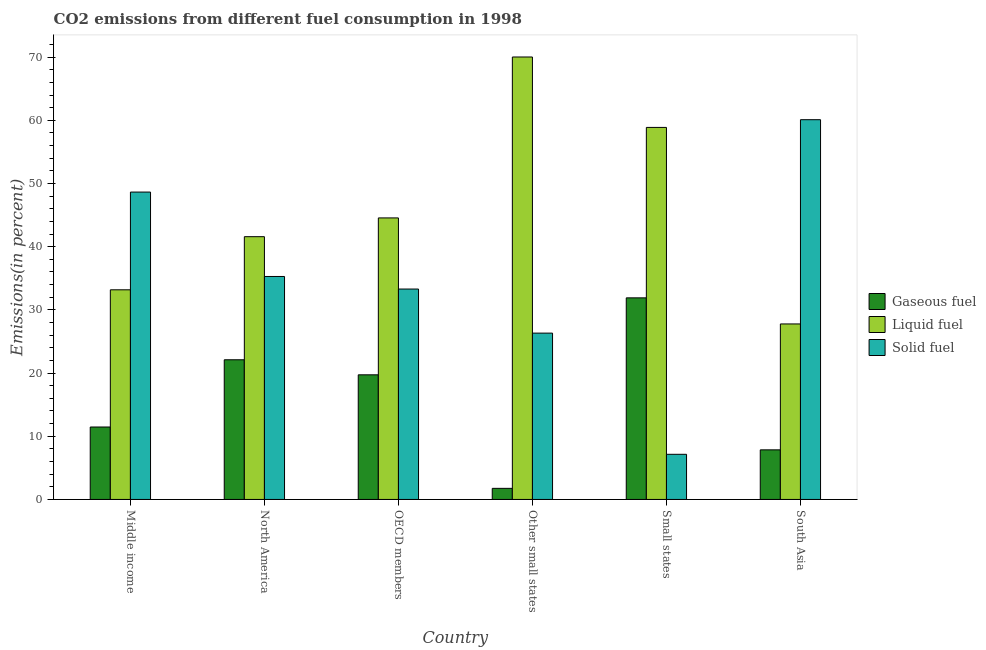How many groups of bars are there?
Give a very brief answer. 6. Are the number of bars per tick equal to the number of legend labels?
Provide a succinct answer. Yes. How many bars are there on the 1st tick from the right?
Keep it short and to the point. 3. What is the label of the 3rd group of bars from the left?
Make the answer very short. OECD members. In how many cases, is the number of bars for a given country not equal to the number of legend labels?
Keep it short and to the point. 0. What is the percentage of gaseous fuel emission in South Asia?
Your response must be concise. 7.85. Across all countries, what is the maximum percentage of gaseous fuel emission?
Your answer should be compact. 31.9. Across all countries, what is the minimum percentage of solid fuel emission?
Provide a succinct answer. 7.14. In which country was the percentage of liquid fuel emission maximum?
Give a very brief answer. Other small states. What is the total percentage of gaseous fuel emission in the graph?
Offer a terse response. 94.81. What is the difference between the percentage of liquid fuel emission in Other small states and that in Small states?
Provide a short and direct response. 11.14. What is the difference between the percentage of solid fuel emission in OECD members and the percentage of gaseous fuel emission in North America?
Keep it short and to the point. 11.19. What is the average percentage of gaseous fuel emission per country?
Your response must be concise. 15.8. What is the difference between the percentage of solid fuel emission and percentage of gaseous fuel emission in Middle income?
Give a very brief answer. 37.18. In how many countries, is the percentage of liquid fuel emission greater than 58 %?
Your response must be concise. 2. What is the ratio of the percentage of solid fuel emission in Middle income to that in Other small states?
Provide a succinct answer. 1.85. Is the percentage of gaseous fuel emission in Middle income less than that in Other small states?
Provide a succinct answer. No. Is the difference between the percentage of liquid fuel emission in Middle income and OECD members greater than the difference between the percentage of gaseous fuel emission in Middle income and OECD members?
Keep it short and to the point. No. What is the difference between the highest and the second highest percentage of liquid fuel emission?
Ensure brevity in your answer.  11.14. What is the difference between the highest and the lowest percentage of gaseous fuel emission?
Your answer should be very brief. 30.15. In how many countries, is the percentage of solid fuel emission greater than the average percentage of solid fuel emission taken over all countries?
Your response must be concise. 3. Is the sum of the percentage of gaseous fuel emission in Middle income and Small states greater than the maximum percentage of liquid fuel emission across all countries?
Your response must be concise. No. What does the 2nd bar from the left in North America represents?
Keep it short and to the point. Liquid fuel. What does the 1st bar from the right in South Asia represents?
Ensure brevity in your answer.  Solid fuel. Is it the case that in every country, the sum of the percentage of gaseous fuel emission and percentage of liquid fuel emission is greater than the percentage of solid fuel emission?
Offer a very short reply. No. How many bars are there?
Your answer should be compact. 18. Are all the bars in the graph horizontal?
Your answer should be very brief. No. How many countries are there in the graph?
Make the answer very short. 6. Does the graph contain any zero values?
Your response must be concise. No. Where does the legend appear in the graph?
Your answer should be very brief. Center right. How many legend labels are there?
Provide a short and direct response. 3. What is the title of the graph?
Ensure brevity in your answer.  CO2 emissions from different fuel consumption in 1998. Does "Natural gas sources" appear as one of the legend labels in the graph?
Keep it short and to the point. No. What is the label or title of the X-axis?
Your answer should be compact. Country. What is the label or title of the Y-axis?
Your answer should be compact. Emissions(in percent). What is the Emissions(in percent) in Gaseous fuel in Middle income?
Provide a short and direct response. 11.47. What is the Emissions(in percent) of Liquid fuel in Middle income?
Your answer should be very brief. 33.18. What is the Emissions(in percent) of Solid fuel in Middle income?
Provide a succinct answer. 48.64. What is the Emissions(in percent) in Gaseous fuel in North America?
Your answer should be compact. 22.11. What is the Emissions(in percent) in Liquid fuel in North America?
Your answer should be very brief. 41.59. What is the Emissions(in percent) of Solid fuel in North America?
Keep it short and to the point. 35.29. What is the Emissions(in percent) in Gaseous fuel in OECD members?
Provide a short and direct response. 19.73. What is the Emissions(in percent) of Liquid fuel in OECD members?
Keep it short and to the point. 44.55. What is the Emissions(in percent) in Solid fuel in OECD members?
Provide a short and direct response. 33.3. What is the Emissions(in percent) of Gaseous fuel in Other small states?
Provide a succinct answer. 1.76. What is the Emissions(in percent) in Liquid fuel in Other small states?
Provide a succinct answer. 70.02. What is the Emissions(in percent) of Solid fuel in Other small states?
Provide a succinct answer. 26.32. What is the Emissions(in percent) in Gaseous fuel in Small states?
Keep it short and to the point. 31.9. What is the Emissions(in percent) of Liquid fuel in Small states?
Your response must be concise. 58.88. What is the Emissions(in percent) in Solid fuel in Small states?
Provide a short and direct response. 7.14. What is the Emissions(in percent) of Gaseous fuel in South Asia?
Make the answer very short. 7.85. What is the Emissions(in percent) of Liquid fuel in South Asia?
Your answer should be very brief. 27.78. What is the Emissions(in percent) of Solid fuel in South Asia?
Your response must be concise. 60.1. Across all countries, what is the maximum Emissions(in percent) in Gaseous fuel?
Keep it short and to the point. 31.9. Across all countries, what is the maximum Emissions(in percent) of Liquid fuel?
Your answer should be compact. 70.02. Across all countries, what is the maximum Emissions(in percent) in Solid fuel?
Your response must be concise. 60.1. Across all countries, what is the minimum Emissions(in percent) in Gaseous fuel?
Your answer should be very brief. 1.76. Across all countries, what is the minimum Emissions(in percent) in Liquid fuel?
Offer a terse response. 27.78. Across all countries, what is the minimum Emissions(in percent) in Solid fuel?
Offer a very short reply. 7.14. What is the total Emissions(in percent) of Gaseous fuel in the graph?
Make the answer very short. 94.81. What is the total Emissions(in percent) in Liquid fuel in the graph?
Keep it short and to the point. 276. What is the total Emissions(in percent) in Solid fuel in the graph?
Make the answer very short. 210.8. What is the difference between the Emissions(in percent) of Gaseous fuel in Middle income and that in North America?
Ensure brevity in your answer.  -10.64. What is the difference between the Emissions(in percent) of Liquid fuel in Middle income and that in North America?
Your answer should be very brief. -8.41. What is the difference between the Emissions(in percent) of Solid fuel in Middle income and that in North America?
Ensure brevity in your answer.  13.36. What is the difference between the Emissions(in percent) of Gaseous fuel in Middle income and that in OECD members?
Keep it short and to the point. -8.26. What is the difference between the Emissions(in percent) in Liquid fuel in Middle income and that in OECD members?
Keep it short and to the point. -11.38. What is the difference between the Emissions(in percent) in Solid fuel in Middle income and that in OECD members?
Make the answer very short. 15.35. What is the difference between the Emissions(in percent) in Gaseous fuel in Middle income and that in Other small states?
Your answer should be compact. 9.71. What is the difference between the Emissions(in percent) of Liquid fuel in Middle income and that in Other small states?
Your response must be concise. -36.84. What is the difference between the Emissions(in percent) of Solid fuel in Middle income and that in Other small states?
Keep it short and to the point. 22.32. What is the difference between the Emissions(in percent) of Gaseous fuel in Middle income and that in Small states?
Offer a terse response. -20.44. What is the difference between the Emissions(in percent) in Liquid fuel in Middle income and that in Small states?
Provide a succinct answer. -25.7. What is the difference between the Emissions(in percent) of Solid fuel in Middle income and that in Small states?
Your answer should be compact. 41.5. What is the difference between the Emissions(in percent) of Gaseous fuel in Middle income and that in South Asia?
Offer a very short reply. 3.61. What is the difference between the Emissions(in percent) in Liquid fuel in Middle income and that in South Asia?
Your response must be concise. 5.4. What is the difference between the Emissions(in percent) of Solid fuel in Middle income and that in South Asia?
Your answer should be very brief. -11.46. What is the difference between the Emissions(in percent) of Gaseous fuel in North America and that in OECD members?
Provide a succinct answer. 2.38. What is the difference between the Emissions(in percent) of Liquid fuel in North America and that in OECD members?
Ensure brevity in your answer.  -2.97. What is the difference between the Emissions(in percent) of Solid fuel in North America and that in OECD members?
Offer a very short reply. 1.99. What is the difference between the Emissions(in percent) of Gaseous fuel in North America and that in Other small states?
Give a very brief answer. 20.35. What is the difference between the Emissions(in percent) of Liquid fuel in North America and that in Other small states?
Your answer should be compact. -28.44. What is the difference between the Emissions(in percent) of Solid fuel in North America and that in Other small states?
Offer a very short reply. 8.96. What is the difference between the Emissions(in percent) in Gaseous fuel in North America and that in Small states?
Offer a very short reply. -9.8. What is the difference between the Emissions(in percent) in Liquid fuel in North America and that in Small states?
Provide a short and direct response. -17.29. What is the difference between the Emissions(in percent) in Solid fuel in North America and that in Small states?
Make the answer very short. 28.14. What is the difference between the Emissions(in percent) in Gaseous fuel in North America and that in South Asia?
Keep it short and to the point. 14.26. What is the difference between the Emissions(in percent) of Liquid fuel in North America and that in South Asia?
Your answer should be very brief. 13.81. What is the difference between the Emissions(in percent) in Solid fuel in North America and that in South Asia?
Offer a terse response. -24.81. What is the difference between the Emissions(in percent) in Gaseous fuel in OECD members and that in Other small states?
Keep it short and to the point. 17.97. What is the difference between the Emissions(in percent) in Liquid fuel in OECD members and that in Other small states?
Provide a succinct answer. -25.47. What is the difference between the Emissions(in percent) of Solid fuel in OECD members and that in Other small states?
Give a very brief answer. 6.98. What is the difference between the Emissions(in percent) in Gaseous fuel in OECD members and that in Small states?
Make the answer very short. -12.18. What is the difference between the Emissions(in percent) in Liquid fuel in OECD members and that in Small states?
Provide a short and direct response. -14.32. What is the difference between the Emissions(in percent) in Solid fuel in OECD members and that in Small states?
Make the answer very short. 26.15. What is the difference between the Emissions(in percent) of Gaseous fuel in OECD members and that in South Asia?
Give a very brief answer. 11.87. What is the difference between the Emissions(in percent) in Liquid fuel in OECD members and that in South Asia?
Offer a terse response. 16.78. What is the difference between the Emissions(in percent) of Solid fuel in OECD members and that in South Asia?
Provide a short and direct response. -26.8. What is the difference between the Emissions(in percent) of Gaseous fuel in Other small states and that in Small states?
Offer a terse response. -30.15. What is the difference between the Emissions(in percent) of Liquid fuel in Other small states and that in Small states?
Keep it short and to the point. 11.14. What is the difference between the Emissions(in percent) of Solid fuel in Other small states and that in Small states?
Your answer should be very brief. 19.18. What is the difference between the Emissions(in percent) of Gaseous fuel in Other small states and that in South Asia?
Your answer should be compact. -6.09. What is the difference between the Emissions(in percent) in Liquid fuel in Other small states and that in South Asia?
Your response must be concise. 42.25. What is the difference between the Emissions(in percent) in Solid fuel in Other small states and that in South Asia?
Provide a succinct answer. -33.78. What is the difference between the Emissions(in percent) in Gaseous fuel in Small states and that in South Asia?
Your answer should be very brief. 24.05. What is the difference between the Emissions(in percent) in Liquid fuel in Small states and that in South Asia?
Offer a terse response. 31.1. What is the difference between the Emissions(in percent) of Solid fuel in Small states and that in South Asia?
Your answer should be compact. -52.96. What is the difference between the Emissions(in percent) in Gaseous fuel in Middle income and the Emissions(in percent) in Liquid fuel in North America?
Provide a succinct answer. -30.12. What is the difference between the Emissions(in percent) in Gaseous fuel in Middle income and the Emissions(in percent) in Solid fuel in North America?
Offer a very short reply. -23.82. What is the difference between the Emissions(in percent) in Liquid fuel in Middle income and the Emissions(in percent) in Solid fuel in North America?
Your answer should be compact. -2.11. What is the difference between the Emissions(in percent) of Gaseous fuel in Middle income and the Emissions(in percent) of Liquid fuel in OECD members?
Your answer should be compact. -33.09. What is the difference between the Emissions(in percent) in Gaseous fuel in Middle income and the Emissions(in percent) in Solid fuel in OECD members?
Offer a terse response. -21.83. What is the difference between the Emissions(in percent) in Liquid fuel in Middle income and the Emissions(in percent) in Solid fuel in OECD members?
Make the answer very short. -0.12. What is the difference between the Emissions(in percent) of Gaseous fuel in Middle income and the Emissions(in percent) of Liquid fuel in Other small states?
Provide a succinct answer. -58.56. What is the difference between the Emissions(in percent) of Gaseous fuel in Middle income and the Emissions(in percent) of Solid fuel in Other small states?
Give a very brief answer. -14.86. What is the difference between the Emissions(in percent) in Liquid fuel in Middle income and the Emissions(in percent) in Solid fuel in Other small states?
Offer a terse response. 6.85. What is the difference between the Emissions(in percent) of Gaseous fuel in Middle income and the Emissions(in percent) of Liquid fuel in Small states?
Keep it short and to the point. -47.41. What is the difference between the Emissions(in percent) in Gaseous fuel in Middle income and the Emissions(in percent) in Solid fuel in Small states?
Provide a succinct answer. 4.32. What is the difference between the Emissions(in percent) of Liquid fuel in Middle income and the Emissions(in percent) of Solid fuel in Small states?
Your response must be concise. 26.03. What is the difference between the Emissions(in percent) in Gaseous fuel in Middle income and the Emissions(in percent) in Liquid fuel in South Asia?
Provide a short and direct response. -16.31. What is the difference between the Emissions(in percent) of Gaseous fuel in Middle income and the Emissions(in percent) of Solid fuel in South Asia?
Your answer should be compact. -48.63. What is the difference between the Emissions(in percent) of Liquid fuel in Middle income and the Emissions(in percent) of Solid fuel in South Asia?
Your response must be concise. -26.92. What is the difference between the Emissions(in percent) in Gaseous fuel in North America and the Emissions(in percent) in Liquid fuel in OECD members?
Offer a very short reply. -22.45. What is the difference between the Emissions(in percent) of Gaseous fuel in North America and the Emissions(in percent) of Solid fuel in OECD members?
Your response must be concise. -11.19. What is the difference between the Emissions(in percent) in Liquid fuel in North America and the Emissions(in percent) in Solid fuel in OECD members?
Your answer should be compact. 8.29. What is the difference between the Emissions(in percent) of Gaseous fuel in North America and the Emissions(in percent) of Liquid fuel in Other small states?
Offer a terse response. -47.92. What is the difference between the Emissions(in percent) of Gaseous fuel in North America and the Emissions(in percent) of Solid fuel in Other small states?
Your response must be concise. -4.22. What is the difference between the Emissions(in percent) of Liquid fuel in North America and the Emissions(in percent) of Solid fuel in Other small states?
Your answer should be compact. 15.26. What is the difference between the Emissions(in percent) in Gaseous fuel in North America and the Emissions(in percent) in Liquid fuel in Small states?
Keep it short and to the point. -36.77. What is the difference between the Emissions(in percent) in Gaseous fuel in North America and the Emissions(in percent) in Solid fuel in Small states?
Provide a short and direct response. 14.96. What is the difference between the Emissions(in percent) of Liquid fuel in North America and the Emissions(in percent) of Solid fuel in Small states?
Provide a succinct answer. 34.44. What is the difference between the Emissions(in percent) in Gaseous fuel in North America and the Emissions(in percent) in Liquid fuel in South Asia?
Offer a very short reply. -5.67. What is the difference between the Emissions(in percent) of Gaseous fuel in North America and the Emissions(in percent) of Solid fuel in South Asia?
Keep it short and to the point. -37.99. What is the difference between the Emissions(in percent) of Liquid fuel in North America and the Emissions(in percent) of Solid fuel in South Asia?
Your response must be concise. -18.51. What is the difference between the Emissions(in percent) in Gaseous fuel in OECD members and the Emissions(in percent) in Liquid fuel in Other small states?
Give a very brief answer. -50.3. What is the difference between the Emissions(in percent) of Gaseous fuel in OECD members and the Emissions(in percent) of Solid fuel in Other small states?
Provide a succinct answer. -6.6. What is the difference between the Emissions(in percent) in Liquid fuel in OECD members and the Emissions(in percent) in Solid fuel in Other small states?
Provide a succinct answer. 18.23. What is the difference between the Emissions(in percent) in Gaseous fuel in OECD members and the Emissions(in percent) in Liquid fuel in Small states?
Offer a very short reply. -39.15. What is the difference between the Emissions(in percent) of Gaseous fuel in OECD members and the Emissions(in percent) of Solid fuel in Small states?
Give a very brief answer. 12.58. What is the difference between the Emissions(in percent) of Liquid fuel in OECD members and the Emissions(in percent) of Solid fuel in Small states?
Your answer should be very brief. 37.41. What is the difference between the Emissions(in percent) of Gaseous fuel in OECD members and the Emissions(in percent) of Liquid fuel in South Asia?
Offer a very short reply. -8.05. What is the difference between the Emissions(in percent) of Gaseous fuel in OECD members and the Emissions(in percent) of Solid fuel in South Asia?
Your response must be concise. -40.38. What is the difference between the Emissions(in percent) of Liquid fuel in OECD members and the Emissions(in percent) of Solid fuel in South Asia?
Offer a terse response. -15.55. What is the difference between the Emissions(in percent) of Gaseous fuel in Other small states and the Emissions(in percent) of Liquid fuel in Small states?
Offer a very short reply. -57.12. What is the difference between the Emissions(in percent) of Gaseous fuel in Other small states and the Emissions(in percent) of Solid fuel in Small states?
Your answer should be very brief. -5.39. What is the difference between the Emissions(in percent) of Liquid fuel in Other small states and the Emissions(in percent) of Solid fuel in Small states?
Your answer should be very brief. 62.88. What is the difference between the Emissions(in percent) of Gaseous fuel in Other small states and the Emissions(in percent) of Liquid fuel in South Asia?
Offer a terse response. -26.02. What is the difference between the Emissions(in percent) of Gaseous fuel in Other small states and the Emissions(in percent) of Solid fuel in South Asia?
Your answer should be compact. -58.34. What is the difference between the Emissions(in percent) of Liquid fuel in Other small states and the Emissions(in percent) of Solid fuel in South Asia?
Keep it short and to the point. 9.92. What is the difference between the Emissions(in percent) of Gaseous fuel in Small states and the Emissions(in percent) of Liquid fuel in South Asia?
Provide a succinct answer. 4.13. What is the difference between the Emissions(in percent) of Gaseous fuel in Small states and the Emissions(in percent) of Solid fuel in South Asia?
Provide a short and direct response. -28.2. What is the difference between the Emissions(in percent) of Liquid fuel in Small states and the Emissions(in percent) of Solid fuel in South Asia?
Provide a succinct answer. -1.22. What is the average Emissions(in percent) of Gaseous fuel per country?
Your response must be concise. 15.8. What is the average Emissions(in percent) in Liquid fuel per country?
Your response must be concise. 46. What is the average Emissions(in percent) of Solid fuel per country?
Keep it short and to the point. 35.13. What is the difference between the Emissions(in percent) in Gaseous fuel and Emissions(in percent) in Liquid fuel in Middle income?
Provide a short and direct response. -21.71. What is the difference between the Emissions(in percent) of Gaseous fuel and Emissions(in percent) of Solid fuel in Middle income?
Your response must be concise. -37.18. What is the difference between the Emissions(in percent) of Liquid fuel and Emissions(in percent) of Solid fuel in Middle income?
Provide a succinct answer. -15.47. What is the difference between the Emissions(in percent) in Gaseous fuel and Emissions(in percent) in Liquid fuel in North America?
Ensure brevity in your answer.  -19.48. What is the difference between the Emissions(in percent) of Gaseous fuel and Emissions(in percent) of Solid fuel in North America?
Provide a succinct answer. -13.18. What is the difference between the Emissions(in percent) of Liquid fuel and Emissions(in percent) of Solid fuel in North America?
Give a very brief answer. 6.3. What is the difference between the Emissions(in percent) of Gaseous fuel and Emissions(in percent) of Liquid fuel in OECD members?
Provide a succinct answer. -24.83. What is the difference between the Emissions(in percent) in Gaseous fuel and Emissions(in percent) in Solid fuel in OECD members?
Ensure brevity in your answer.  -13.57. What is the difference between the Emissions(in percent) in Liquid fuel and Emissions(in percent) in Solid fuel in OECD members?
Your answer should be compact. 11.26. What is the difference between the Emissions(in percent) in Gaseous fuel and Emissions(in percent) in Liquid fuel in Other small states?
Offer a terse response. -68.27. What is the difference between the Emissions(in percent) of Gaseous fuel and Emissions(in percent) of Solid fuel in Other small states?
Your answer should be compact. -24.57. What is the difference between the Emissions(in percent) in Liquid fuel and Emissions(in percent) in Solid fuel in Other small states?
Ensure brevity in your answer.  43.7. What is the difference between the Emissions(in percent) of Gaseous fuel and Emissions(in percent) of Liquid fuel in Small states?
Your answer should be compact. -26.97. What is the difference between the Emissions(in percent) in Gaseous fuel and Emissions(in percent) in Solid fuel in Small states?
Your response must be concise. 24.76. What is the difference between the Emissions(in percent) of Liquid fuel and Emissions(in percent) of Solid fuel in Small states?
Offer a terse response. 51.73. What is the difference between the Emissions(in percent) of Gaseous fuel and Emissions(in percent) of Liquid fuel in South Asia?
Your answer should be compact. -19.92. What is the difference between the Emissions(in percent) of Gaseous fuel and Emissions(in percent) of Solid fuel in South Asia?
Your response must be concise. -52.25. What is the difference between the Emissions(in percent) in Liquid fuel and Emissions(in percent) in Solid fuel in South Asia?
Your answer should be very brief. -32.32. What is the ratio of the Emissions(in percent) of Gaseous fuel in Middle income to that in North America?
Your answer should be very brief. 0.52. What is the ratio of the Emissions(in percent) of Liquid fuel in Middle income to that in North America?
Your answer should be compact. 0.8. What is the ratio of the Emissions(in percent) of Solid fuel in Middle income to that in North America?
Offer a very short reply. 1.38. What is the ratio of the Emissions(in percent) in Gaseous fuel in Middle income to that in OECD members?
Provide a succinct answer. 0.58. What is the ratio of the Emissions(in percent) in Liquid fuel in Middle income to that in OECD members?
Ensure brevity in your answer.  0.74. What is the ratio of the Emissions(in percent) of Solid fuel in Middle income to that in OECD members?
Your response must be concise. 1.46. What is the ratio of the Emissions(in percent) in Gaseous fuel in Middle income to that in Other small states?
Provide a succinct answer. 6.53. What is the ratio of the Emissions(in percent) of Liquid fuel in Middle income to that in Other small states?
Offer a terse response. 0.47. What is the ratio of the Emissions(in percent) of Solid fuel in Middle income to that in Other small states?
Your answer should be very brief. 1.85. What is the ratio of the Emissions(in percent) of Gaseous fuel in Middle income to that in Small states?
Offer a terse response. 0.36. What is the ratio of the Emissions(in percent) of Liquid fuel in Middle income to that in Small states?
Your answer should be compact. 0.56. What is the ratio of the Emissions(in percent) in Solid fuel in Middle income to that in Small states?
Keep it short and to the point. 6.81. What is the ratio of the Emissions(in percent) of Gaseous fuel in Middle income to that in South Asia?
Offer a terse response. 1.46. What is the ratio of the Emissions(in percent) in Liquid fuel in Middle income to that in South Asia?
Give a very brief answer. 1.19. What is the ratio of the Emissions(in percent) of Solid fuel in Middle income to that in South Asia?
Your response must be concise. 0.81. What is the ratio of the Emissions(in percent) in Gaseous fuel in North America to that in OECD members?
Offer a very short reply. 1.12. What is the ratio of the Emissions(in percent) in Liquid fuel in North America to that in OECD members?
Offer a terse response. 0.93. What is the ratio of the Emissions(in percent) of Solid fuel in North America to that in OECD members?
Offer a very short reply. 1.06. What is the ratio of the Emissions(in percent) in Gaseous fuel in North America to that in Other small states?
Your answer should be compact. 12.58. What is the ratio of the Emissions(in percent) in Liquid fuel in North America to that in Other small states?
Your answer should be very brief. 0.59. What is the ratio of the Emissions(in percent) in Solid fuel in North America to that in Other small states?
Offer a very short reply. 1.34. What is the ratio of the Emissions(in percent) in Gaseous fuel in North America to that in Small states?
Offer a very short reply. 0.69. What is the ratio of the Emissions(in percent) in Liquid fuel in North America to that in Small states?
Ensure brevity in your answer.  0.71. What is the ratio of the Emissions(in percent) of Solid fuel in North America to that in Small states?
Your response must be concise. 4.94. What is the ratio of the Emissions(in percent) of Gaseous fuel in North America to that in South Asia?
Offer a terse response. 2.82. What is the ratio of the Emissions(in percent) of Liquid fuel in North America to that in South Asia?
Provide a succinct answer. 1.5. What is the ratio of the Emissions(in percent) in Solid fuel in North America to that in South Asia?
Provide a short and direct response. 0.59. What is the ratio of the Emissions(in percent) of Gaseous fuel in OECD members to that in Other small states?
Give a very brief answer. 11.23. What is the ratio of the Emissions(in percent) in Liquid fuel in OECD members to that in Other small states?
Give a very brief answer. 0.64. What is the ratio of the Emissions(in percent) of Solid fuel in OECD members to that in Other small states?
Ensure brevity in your answer.  1.26. What is the ratio of the Emissions(in percent) of Gaseous fuel in OECD members to that in Small states?
Provide a succinct answer. 0.62. What is the ratio of the Emissions(in percent) of Liquid fuel in OECD members to that in Small states?
Your answer should be very brief. 0.76. What is the ratio of the Emissions(in percent) in Solid fuel in OECD members to that in Small states?
Your answer should be compact. 4.66. What is the ratio of the Emissions(in percent) in Gaseous fuel in OECD members to that in South Asia?
Your answer should be very brief. 2.51. What is the ratio of the Emissions(in percent) of Liquid fuel in OECD members to that in South Asia?
Offer a very short reply. 1.6. What is the ratio of the Emissions(in percent) of Solid fuel in OECD members to that in South Asia?
Give a very brief answer. 0.55. What is the ratio of the Emissions(in percent) of Gaseous fuel in Other small states to that in Small states?
Make the answer very short. 0.06. What is the ratio of the Emissions(in percent) of Liquid fuel in Other small states to that in Small states?
Give a very brief answer. 1.19. What is the ratio of the Emissions(in percent) in Solid fuel in Other small states to that in Small states?
Make the answer very short. 3.68. What is the ratio of the Emissions(in percent) of Gaseous fuel in Other small states to that in South Asia?
Offer a very short reply. 0.22. What is the ratio of the Emissions(in percent) of Liquid fuel in Other small states to that in South Asia?
Offer a terse response. 2.52. What is the ratio of the Emissions(in percent) of Solid fuel in Other small states to that in South Asia?
Keep it short and to the point. 0.44. What is the ratio of the Emissions(in percent) of Gaseous fuel in Small states to that in South Asia?
Offer a very short reply. 4.06. What is the ratio of the Emissions(in percent) in Liquid fuel in Small states to that in South Asia?
Keep it short and to the point. 2.12. What is the ratio of the Emissions(in percent) in Solid fuel in Small states to that in South Asia?
Your answer should be very brief. 0.12. What is the difference between the highest and the second highest Emissions(in percent) of Gaseous fuel?
Offer a terse response. 9.8. What is the difference between the highest and the second highest Emissions(in percent) in Liquid fuel?
Provide a short and direct response. 11.14. What is the difference between the highest and the second highest Emissions(in percent) of Solid fuel?
Make the answer very short. 11.46. What is the difference between the highest and the lowest Emissions(in percent) in Gaseous fuel?
Your answer should be very brief. 30.15. What is the difference between the highest and the lowest Emissions(in percent) of Liquid fuel?
Offer a terse response. 42.25. What is the difference between the highest and the lowest Emissions(in percent) of Solid fuel?
Make the answer very short. 52.96. 